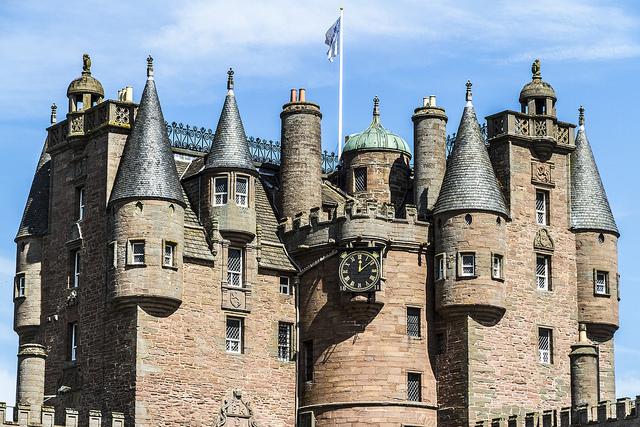How many flags are on this castle?
Short answer required. 1. How many windows are visible?
Keep it brief. 23. Does anyone lives in this castle?
Keep it brief. Yes. 